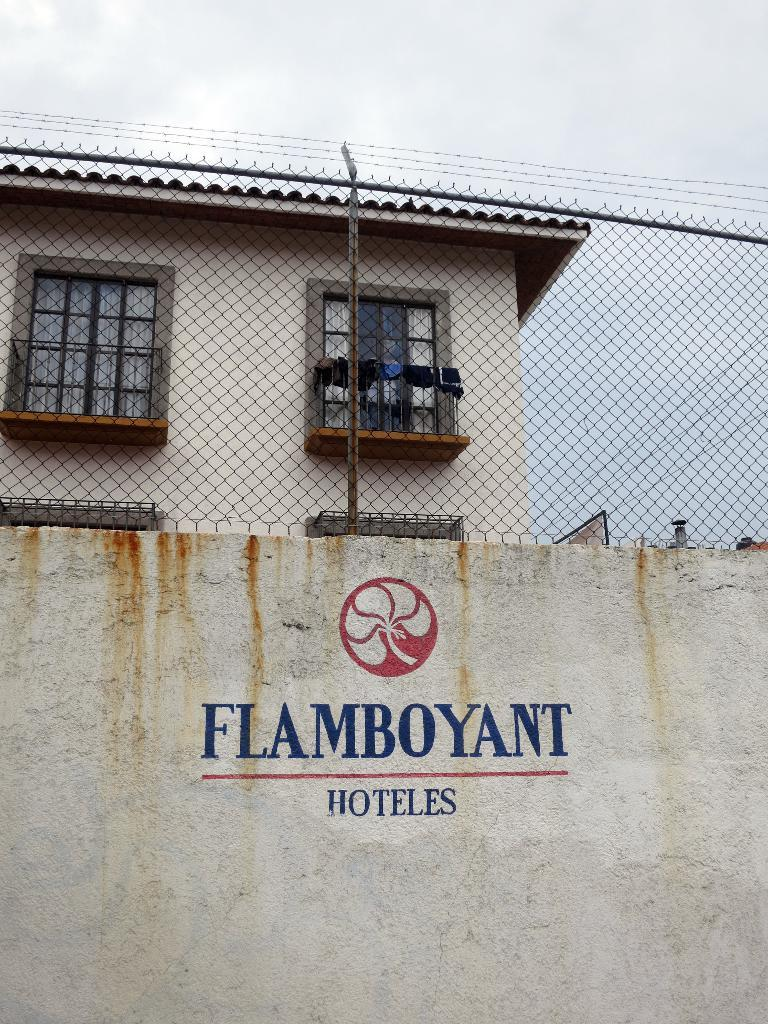What is written or displayed on the wall in the foreground of the image? There is text on a wall in the foreground of the image. What can be seen at the top of the image? There is a mesh at the top of the image. What structure is visible behind the mesh? There is a building visible behind the mesh. What part of the natural environment is visible in the image? The sky is visible in the image. How many ducks are sitting on the vase in the image? There is no vase or duck present in the image. What achievements are being celebrated by the achiever in the image? There is no achiever or indication of achievements in the image. 